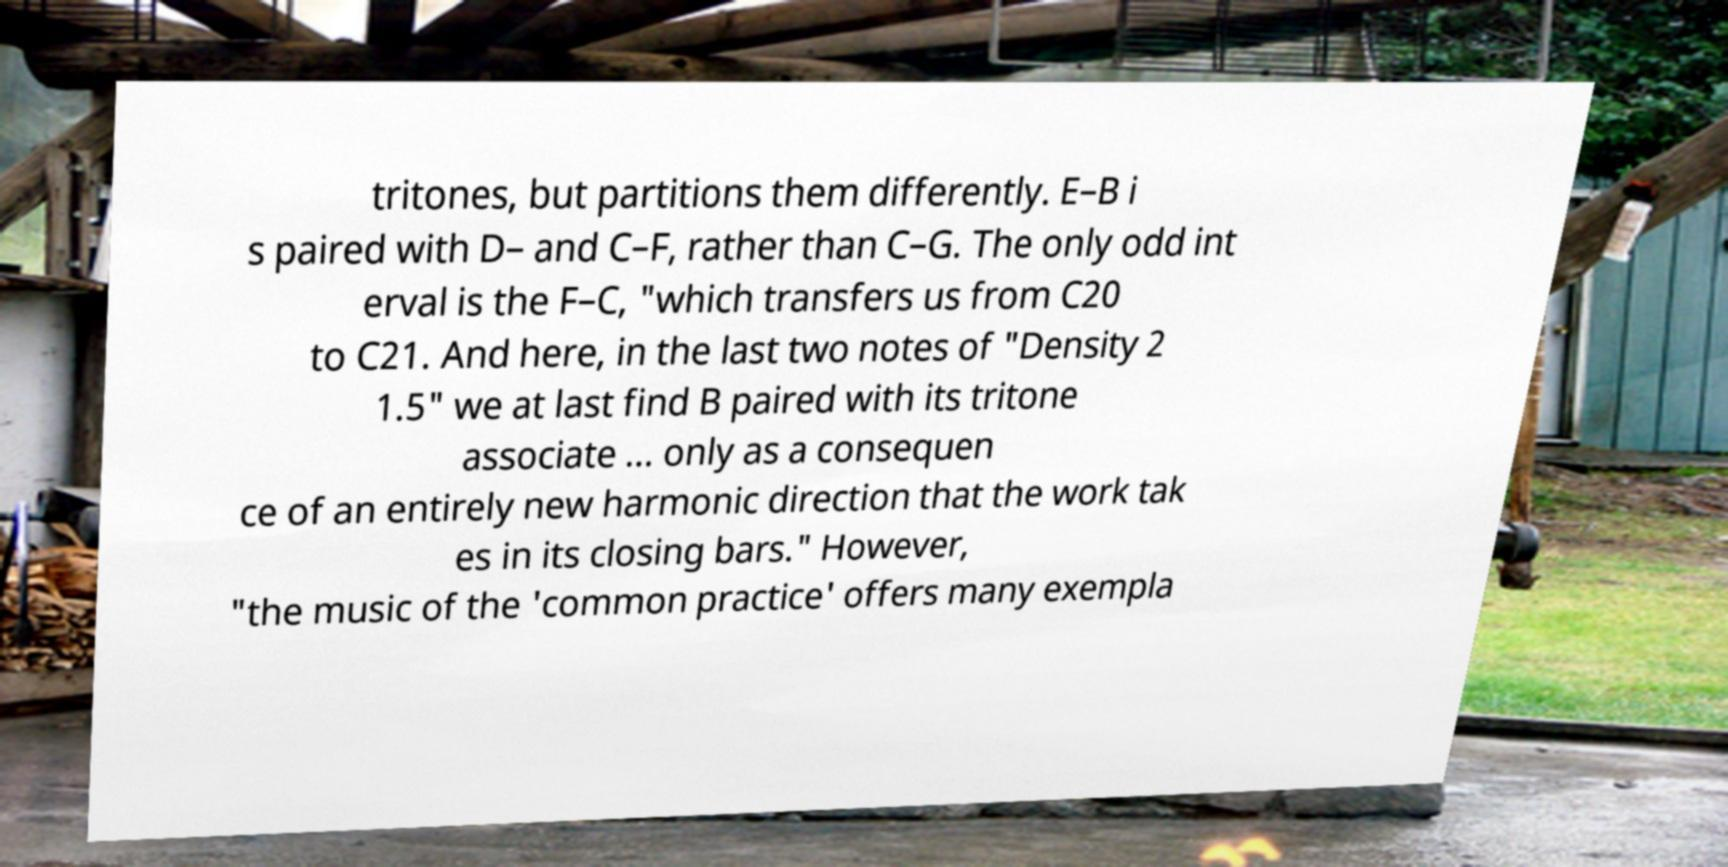Could you assist in decoding the text presented in this image and type it out clearly? tritones, but partitions them differently. E–B i s paired with D– and C–F, rather than C–G. The only odd int erval is the F–C, "which transfers us from C20 to C21. And here, in the last two notes of "Density 2 1.5" we at last find B paired with its tritone associate ... only as a consequen ce of an entirely new harmonic direction that the work tak es in its closing bars." However, "the music of the 'common practice' offers many exempla 